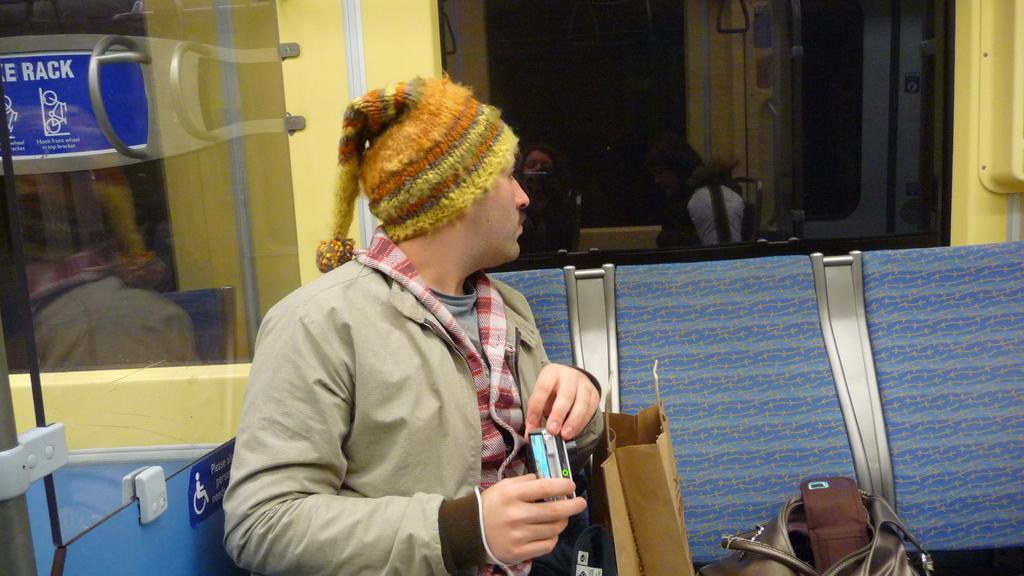Describe this image in one or two sentences. In this image there is a man sitting on bench, in the background there are glass doors, beside him there are bags. 